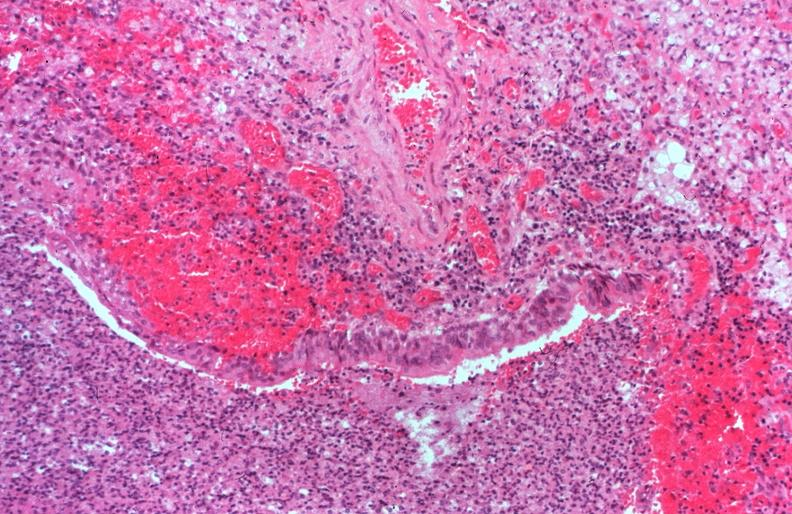s this photo of infant from head to toe present?
Answer the question using a single word or phrase. No 